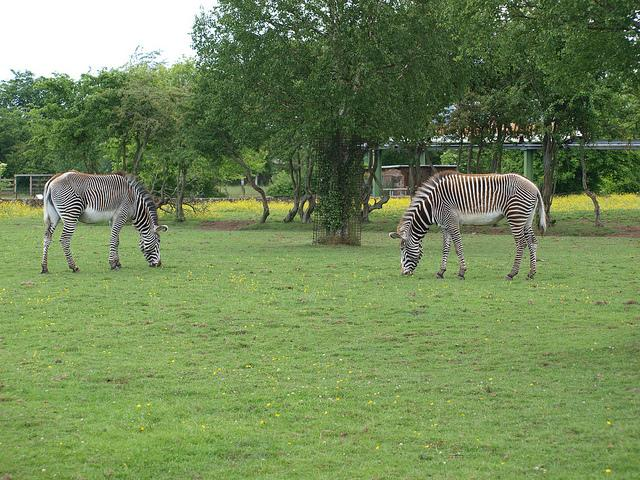The zebras in the middle of the field are busy doing what? eating 